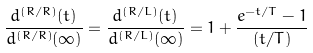<formula> <loc_0><loc_0><loc_500><loc_500>\frac { d ^ { ( R / R ) } ( t ) } { d ^ { ( R / R ) } ( \infty ) } = \frac { d ^ { ( R / L ) } ( t ) } { d ^ { ( R / L ) } ( \infty ) } = 1 + \frac { e ^ { - t / T } - 1 } { ( t / T ) }</formula> 